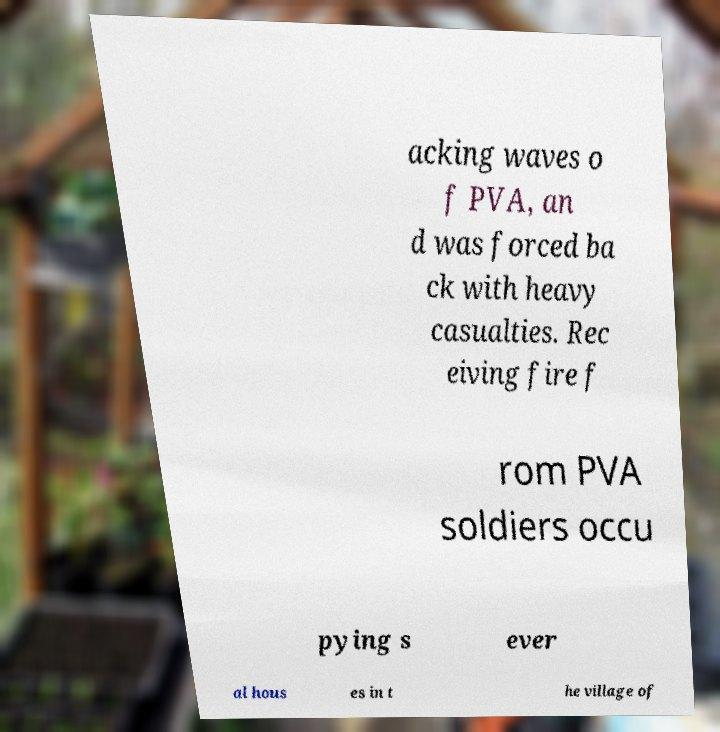I need the written content from this picture converted into text. Can you do that? acking waves o f PVA, an d was forced ba ck with heavy casualties. Rec eiving fire f rom PVA soldiers occu pying s ever al hous es in t he village of 